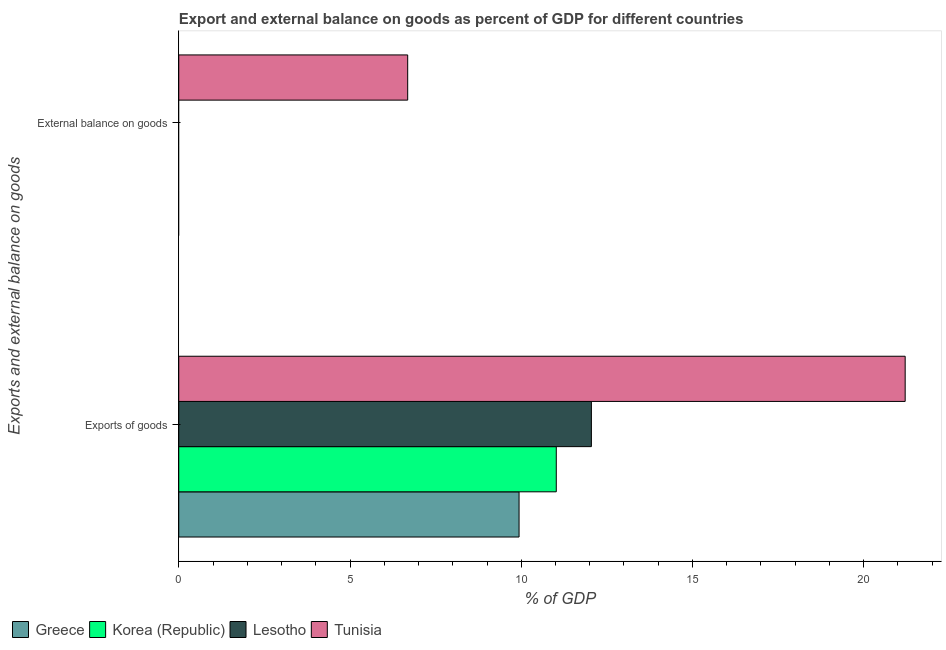Are the number of bars per tick equal to the number of legend labels?
Make the answer very short. No. Are the number of bars on each tick of the Y-axis equal?
Offer a very short reply. No. How many bars are there on the 1st tick from the top?
Keep it short and to the point. 1. What is the label of the 2nd group of bars from the top?
Ensure brevity in your answer.  Exports of goods. Across all countries, what is the maximum external balance on goods as percentage of gdp?
Provide a short and direct response. 6.68. Across all countries, what is the minimum external balance on goods as percentage of gdp?
Your answer should be compact. 0. In which country was the external balance on goods as percentage of gdp maximum?
Provide a short and direct response. Tunisia. What is the total external balance on goods as percentage of gdp in the graph?
Make the answer very short. 6.68. What is the difference between the export of goods as percentage of gdp in Greece and that in Lesotho?
Your answer should be compact. -2.11. What is the difference between the export of goods as percentage of gdp in Korea (Republic) and the external balance on goods as percentage of gdp in Lesotho?
Ensure brevity in your answer.  11.02. What is the average export of goods as percentage of gdp per country?
Offer a very short reply. 13.55. What is the difference between the export of goods as percentage of gdp and external balance on goods as percentage of gdp in Tunisia?
Your response must be concise. 14.53. What is the ratio of the export of goods as percentage of gdp in Lesotho to that in Tunisia?
Make the answer very short. 0.57. Is the export of goods as percentage of gdp in Greece less than that in Korea (Republic)?
Your answer should be very brief. Yes. Are all the bars in the graph horizontal?
Keep it short and to the point. Yes. How many countries are there in the graph?
Keep it short and to the point. 4. What is the difference between two consecutive major ticks on the X-axis?
Offer a very short reply. 5. Are the values on the major ticks of X-axis written in scientific E-notation?
Give a very brief answer. No. Does the graph contain any zero values?
Keep it short and to the point. Yes. Does the graph contain grids?
Provide a succinct answer. No. How are the legend labels stacked?
Offer a very short reply. Horizontal. What is the title of the graph?
Provide a short and direct response. Export and external balance on goods as percent of GDP for different countries. What is the label or title of the X-axis?
Provide a succinct answer. % of GDP. What is the label or title of the Y-axis?
Your response must be concise. Exports and external balance on goods. What is the % of GDP of Greece in Exports of goods?
Give a very brief answer. 9.94. What is the % of GDP of Korea (Republic) in Exports of goods?
Provide a short and direct response. 11.02. What is the % of GDP of Lesotho in Exports of goods?
Keep it short and to the point. 12.05. What is the % of GDP in Tunisia in Exports of goods?
Give a very brief answer. 21.21. What is the % of GDP in Lesotho in External balance on goods?
Provide a succinct answer. 0. What is the % of GDP in Tunisia in External balance on goods?
Give a very brief answer. 6.68. Across all Exports and external balance on goods, what is the maximum % of GDP of Greece?
Your response must be concise. 9.94. Across all Exports and external balance on goods, what is the maximum % of GDP of Korea (Republic)?
Give a very brief answer. 11.02. Across all Exports and external balance on goods, what is the maximum % of GDP of Lesotho?
Your response must be concise. 12.05. Across all Exports and external balance on goods, what is the maximum % of GDP of Tunisia?
Make the answer very short. 21.21. Across all Exports and external balance on goods, what is the minimum % of GDP in Greece?
Offer a terse response. 0. Across all Exports and external balance on goods, what is the minimum % of GDP of Lesotho?
Give a very brief answer. 0. Across all Exports and external balance on goods, what is the minimum % of GDP of Tunisia?
Give a very brief answer. 6.68. What is the total % of GDP of Greece in the graph?
Keep it short and to the point. 9.94. What is the total % of GDP of Korea (Republic) in the graph?
Offer a very short reply. 11.02. What is the total % of GDP of Lesotho in the graph?
Ensure brevity in your answer.  12.05. What is the total % of GDP of Tunisia in the graph?
Provide a succinct answer. 27.89. What is the difference between the % of GDP in Tunisia in Exports of goods and that in External balance on goods?
Your response must be concise. 14.53. What is the difference between the % of GDP in Greece in Exports of goods and the % of GDP in Tunisia in External balance on goods?
Provide a short and direct response. 3.25. What is the difference between the % of GDP in Korea (Republic) in Exports of goods and the % of GDP in Tunisia in External balance on goods?
Your response must be concise. 4.34. What is the difference between the % of GDP in Lesotho in Exports of goods and the % of GDP in Tunisia in External balance on goods?
Give a very brief answer. 5.36. What is the average % of GDP of Greece per Exports and external balance on goods?
Your response must be concise. 4.97. What is the average % of GDP of Korea (Republic) per Exports and external balance on goods?
Give a very brief answer. 5.51. What is the average % of GDP of Lesotho per Exports and external balance on goods?
Offer a very short reply. 6.02. What is the average % of GDP of Tunisia per Exports and external balance on goods?
Provide a short and direct response. 13.95. What is the difference between the % of GDP in Greece and % of GDP in Korea (Republic) in Exports of goods?
Ensure brevity in your answer.  -1.09. What is the difference between the % of GDP of Greece and % of GDP of Lesotho in Exports of goods?
Provide a succinct answer. -2.11. What is the difference between the % of GDP in Greece and % of GDP in Tunisia in Exports of goods?
Provide a short and direct response. -11.27. What is the difference between the % of GDP in Korea (Republic) and % of GDP in Lesotho in Exports of goods?
Provide a succinct answer. -1.03. What is the difference between the % of GDP in Korea (Republic) and % of GDP in Tunisia in Exports of goods?
Offer a very short reply. -10.19. What is the difference between the % of GDP of Lesotho and % of GDP of Tunisia in Exports of goods?
Provide a short and direct response. -9.16. What is the ratio of the % of GDP in Tunisia in Exports of goods to that in External balance on goods?
Ensure brevity in your answer.  3.17. What is the difference between the highest and the second highest % of GDP of Tunisia?
Provide a succinct answer. 14.53. What is the difference between the highest and the lowest % of GDP in Greece?
Provide a short and direct response. 9.94. What is the difference between the highest and the lowest % of GDP of Korea (Republic)?
Ensure brevity in your answer.  11.02. What is the difference between the highest and the lowest % of GDP of Lesotho?
Your answer should be very brief. 12.05. What is the difference between the highest and the lowest % of GDP of Tunisia?
Give a very brief answer. 14.53. 